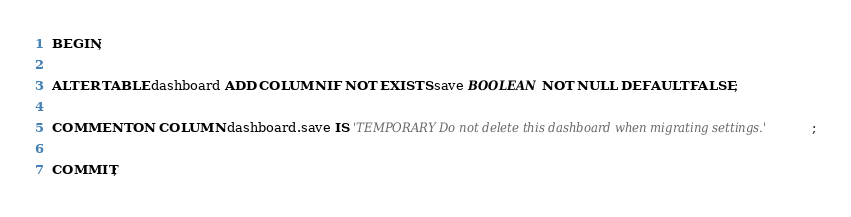<code> <loc_0><loc_0><loc_500><loc_500><_SQL_>BEGIN;

ALTER TABLE dashboard ADD COLUMN IF NOT EXISTS save BOOLEAN NOT NULL DEFAULT FALSE;

COMMENT ON COLUMN dashboard.save IS 'TEMPORARY Do not delete this dashboard when migrating settings.';

COMMIT;
</code> 